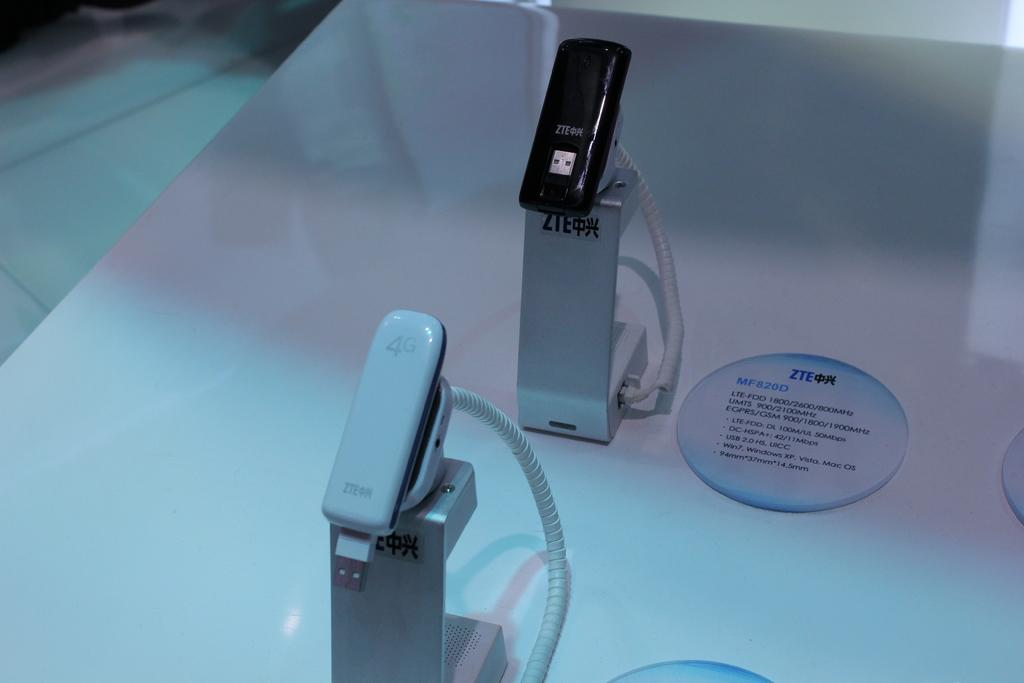<image>
Present a compact description of the photo's key features. Above the white product is a black one and it is model number MF820D. 